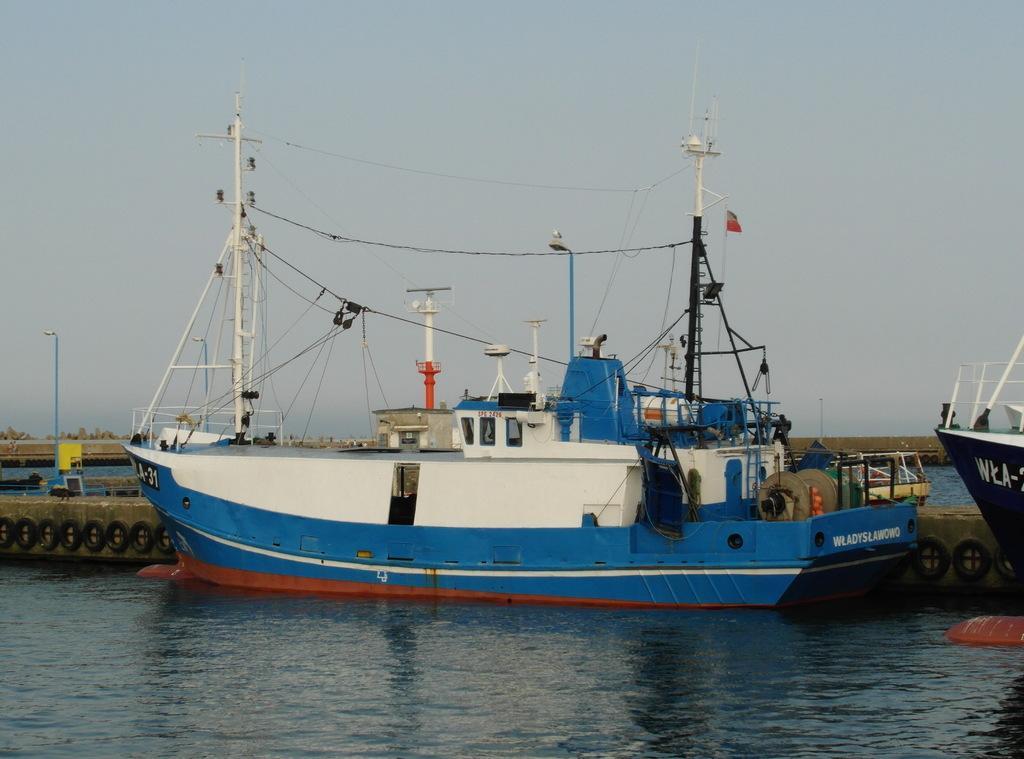Please provide a concise description of this image. In the picture I can see the ships in the water. It is looking like a light pole on the left side. There are clouds in the sky. 